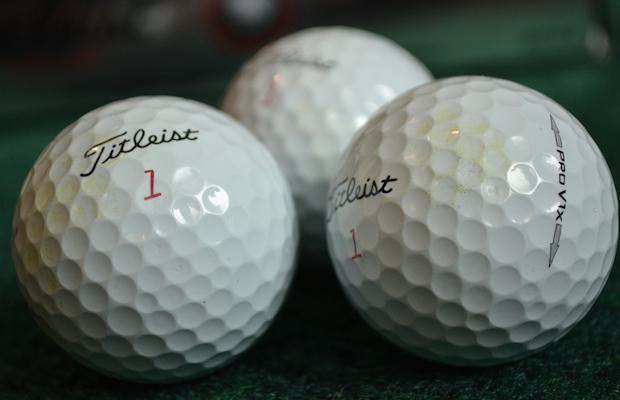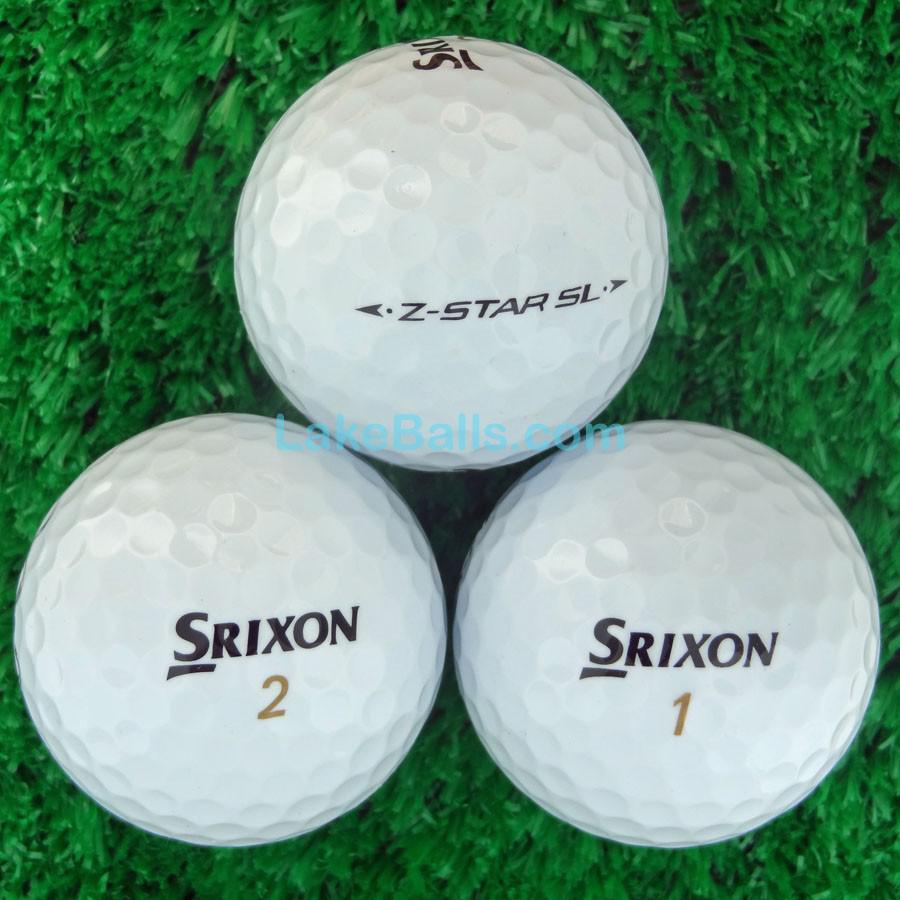The first image is the image on the left, the second image is the image on the right. For the images displayed, is the sentence "The balls in the image on the right are sitting in a green basket." factually correct? Answer yes or no. No. The first image is the image on the left, the second image is the image on the right. For the images shown, is this caption "An image shows a green container filled with only white golf balls." true? Answer yes or no. No. 